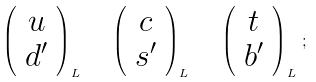Convert formula to latex. <formula><loc_0><loc_0><loc_500><loc_500>\left ( \begin{array} { c } u \\ d ^ { \prime } \end{array} \right ) _ { L } \quad \left ( \begin{array} { c } c \\ s ^ { \prime } \end{array} \right ) _ { L } \quad \left ( \begin{array} { c } t \\ b ^ { \prime } \end{array} \right ) _ { L } \, ;</formula> 